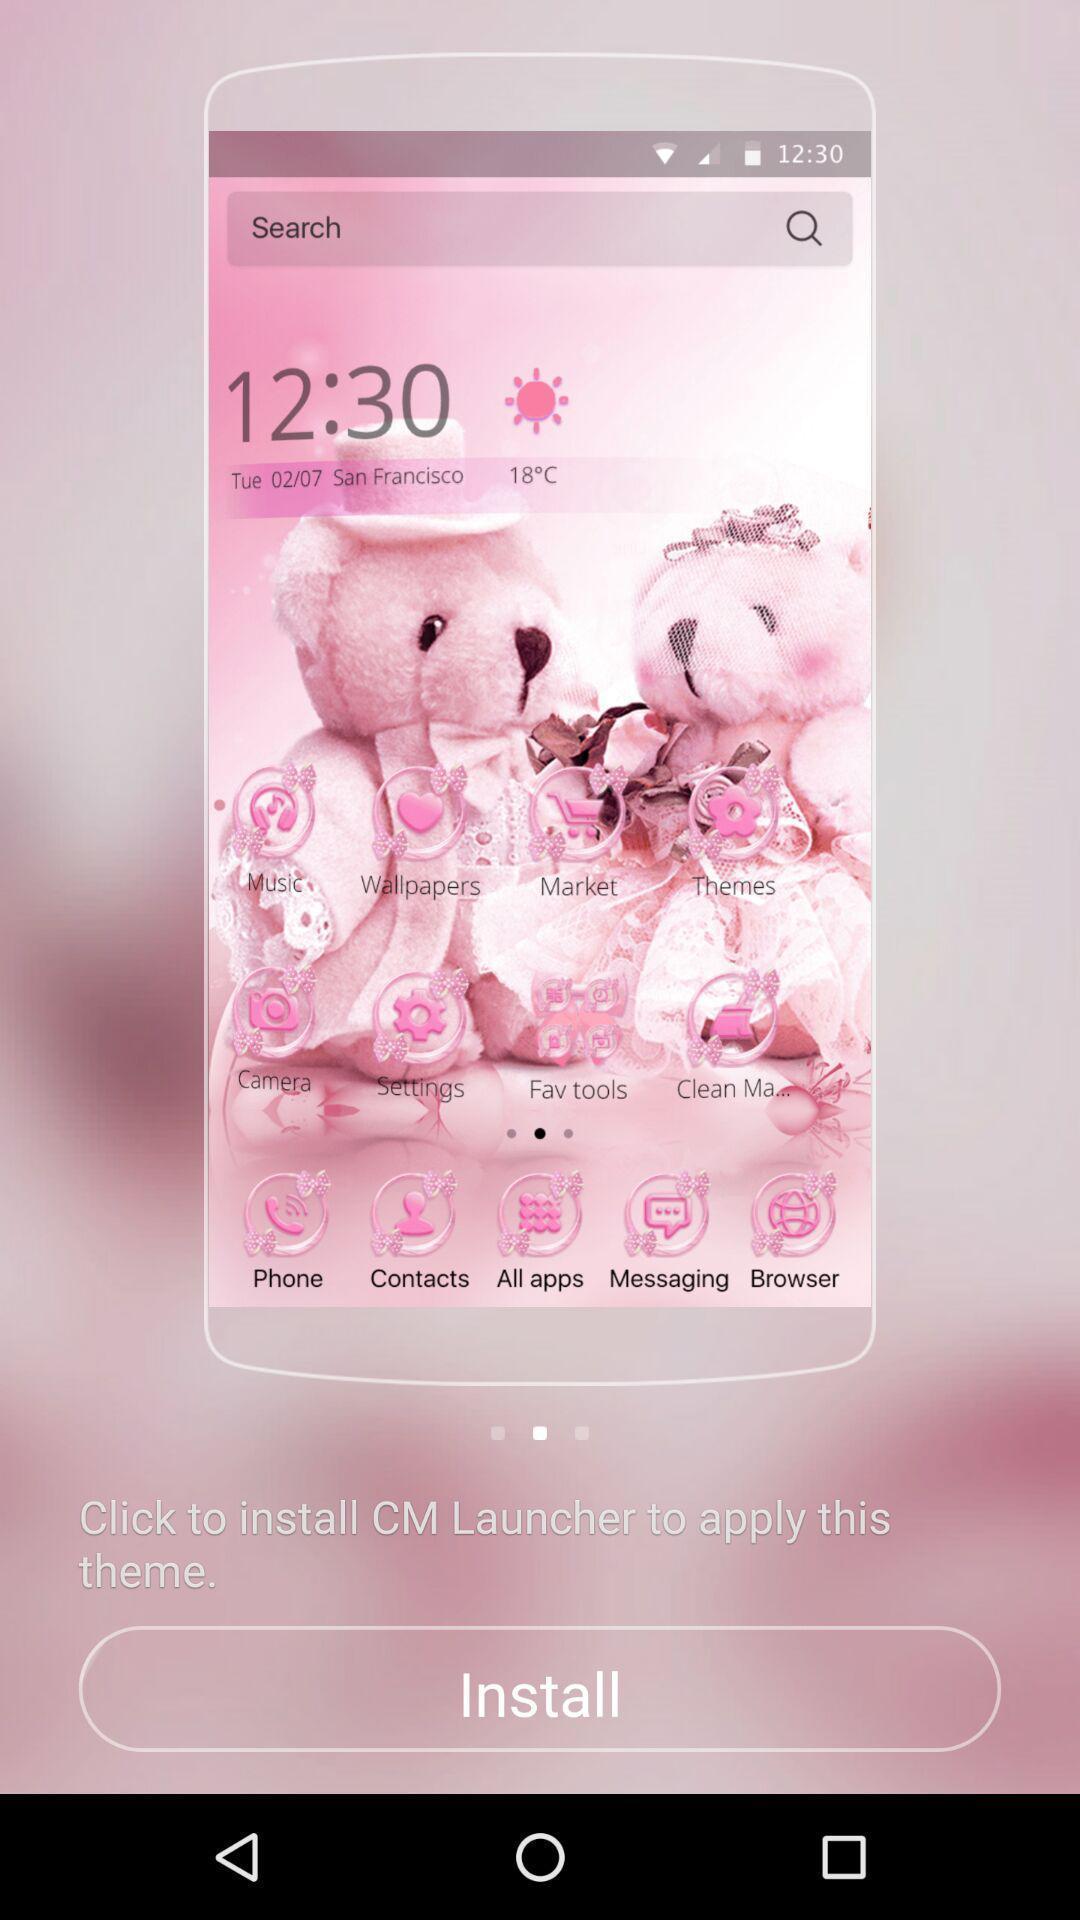Please provide a description for this image. Screen shows install to launch a theme. 